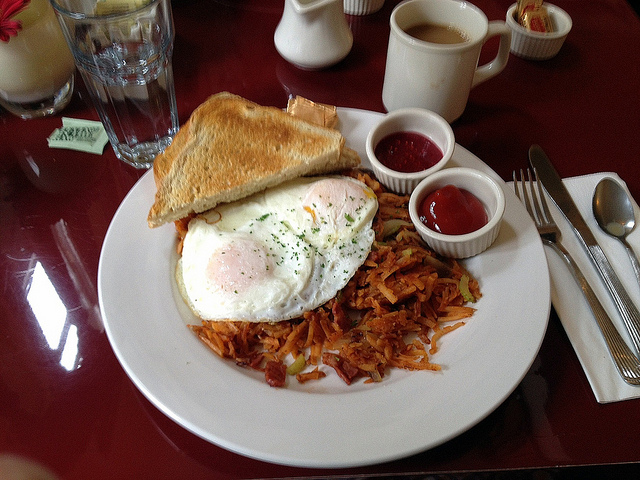Can you suggest a beverage that would pair well with this breakfast? A classic beverage choice to complement this breakfast would be freshly brewed coffee. Its rich, aromatic profile pairs wonderfully with the hearty and savory elements of the meal. Alternatively, for those preferring a non-caffeinated option, a glass of cold orange juice or a smoothie with mixed berries would also provide a refreshing contrast to the savory foods. 